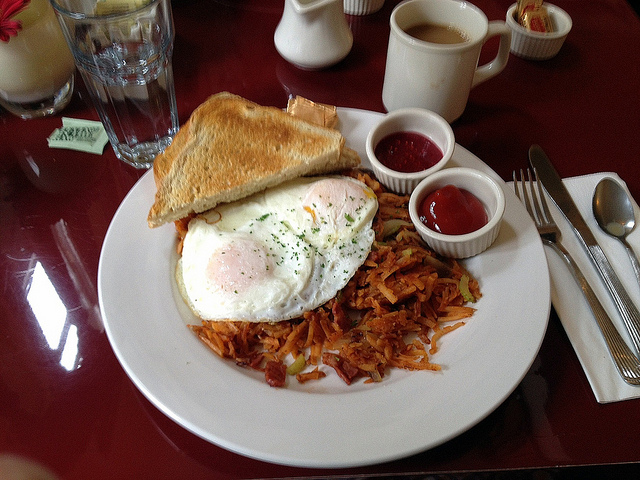Can you suggest a beverage that would pair well with this breakfast? A classic beverage choice to complement this breakfast would be freshly brewed coffee. Its rich, aromatic profile pairs wonderfully with the hearty and savory elements of the meal. Alternatively, for those preferring a non-caffeinated option, a glass of cold orange juice or a smoothie with mixed berries would also provide a refreshing contrast to the savory foods. 